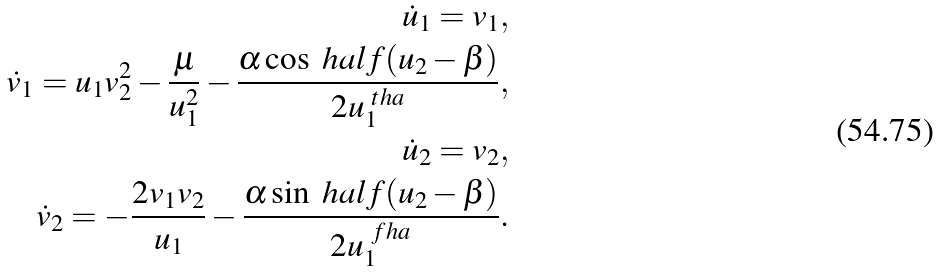Convert formula to latex. <formula><loc_0><loc_0><loc_500><loc_500>\dot { u } _ { 1 } = v _ { 1 } , \\ \dot { v } _ { 1 } = u _ { 1 } v _ { 2 } ^ { 2 } - \frac { \mu } { u _ { 1 } ^ { 2 } } - \frac { \alpha \cos \ h a l f ( u _ { 2 } - \beta ) } { 2 u _ { 1 } ^ { \ t h a } } , \\ \dot { u } _ { 2 } = v _ { 2 } , \\ \dot { v } _ { 2 } = - \frac { 2 v _ { 1 } v _ { 2 } } { u _ { 1 } } - \frac { \alpha \sin \ h a l f ( u _ { 2 } - \beta ) } { 2 u _ { 1 } ^ { \ f h a } } .</formula> 